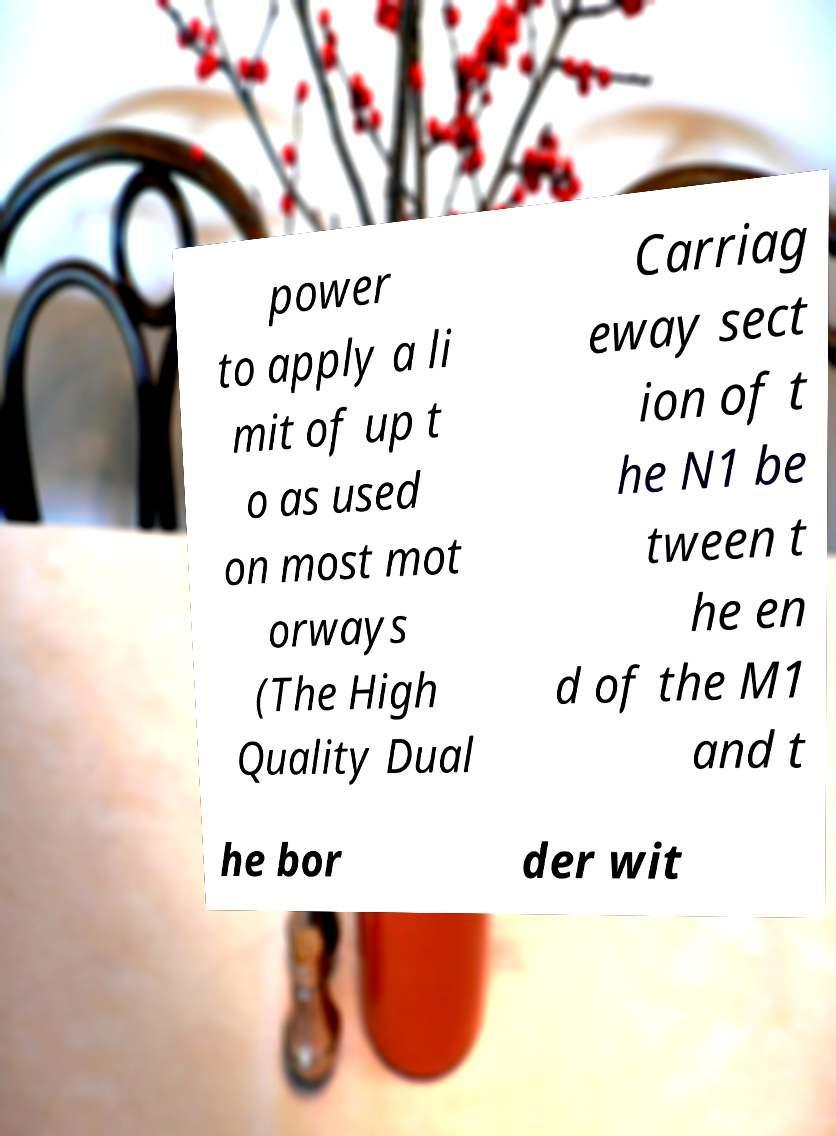What messages or text are displayed in this image? I need them in a readable, typed format. power to apply a li mit of up t o as used on most mot orways (The High Quality Dual Carriag eway sect ion of t he N1 be tween t he en d of the M1 and t he bor der wit 